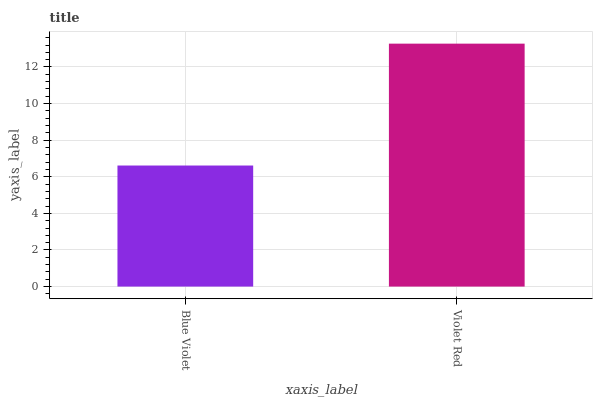Is Blue Violet the minimum?
Answer yes or no. Yes. Is Violet Red the maximum?
Answer yes or no. Yes. Is Violet Red the minimum?
Answer yes or no. No. Is Violet Red greater than Blue Violet?
Answer yes or no. Yes. Is Blue Violet less than Violet Red?
Answer yes or no. Yes. Is Blue Violet greater than Violet Red?
Answer yes or no. No. Is Violet Red less than Blue Violet?
Answer yes or no. No. Is Violet Red the high median?
Answer yes or no. Yes. Is Blue Violet the low median?
Answer yes or no. Yes. Is Blue Violet the high median?
Answer yes or no. No. Is Violet Red the low median?
Answer yes or no. No. 